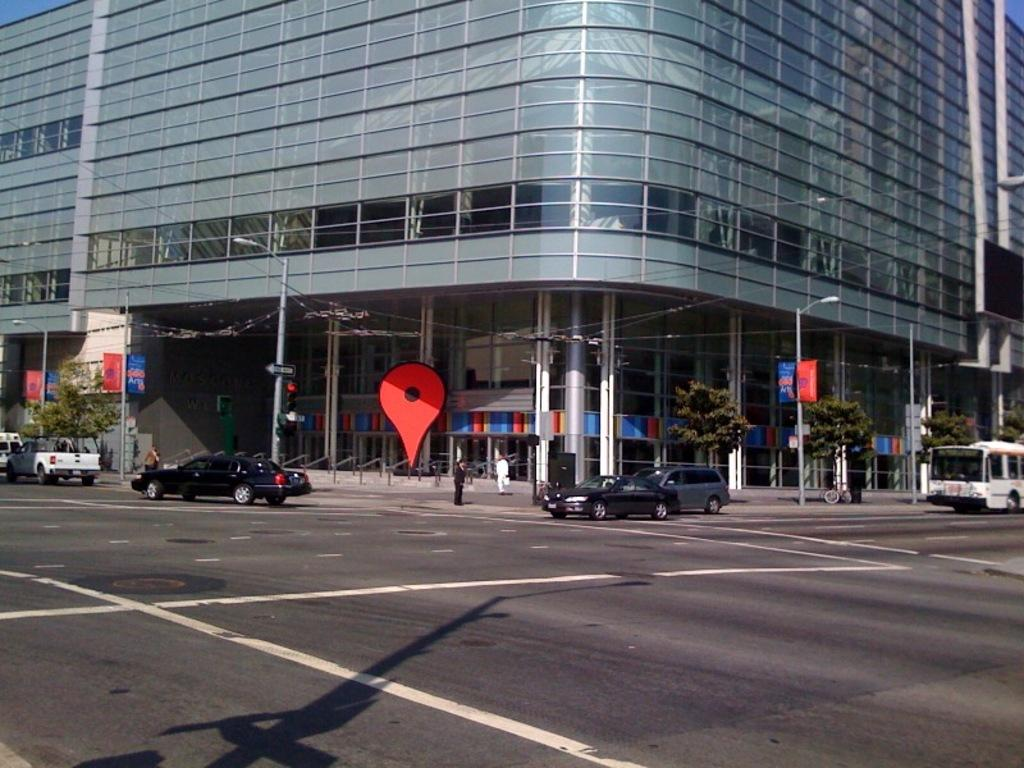What is in the foreground of the image? There is a road in the foreground of the image. What is happening on the road? Vehicles are moving on the road. What can be seen in the background of the image? There are poles, banners, trees, and a building in the background of the image. What type of plastic is used to make the feather in the image? There is no feather present in the image, and therefore no plastic can be associated with it. 